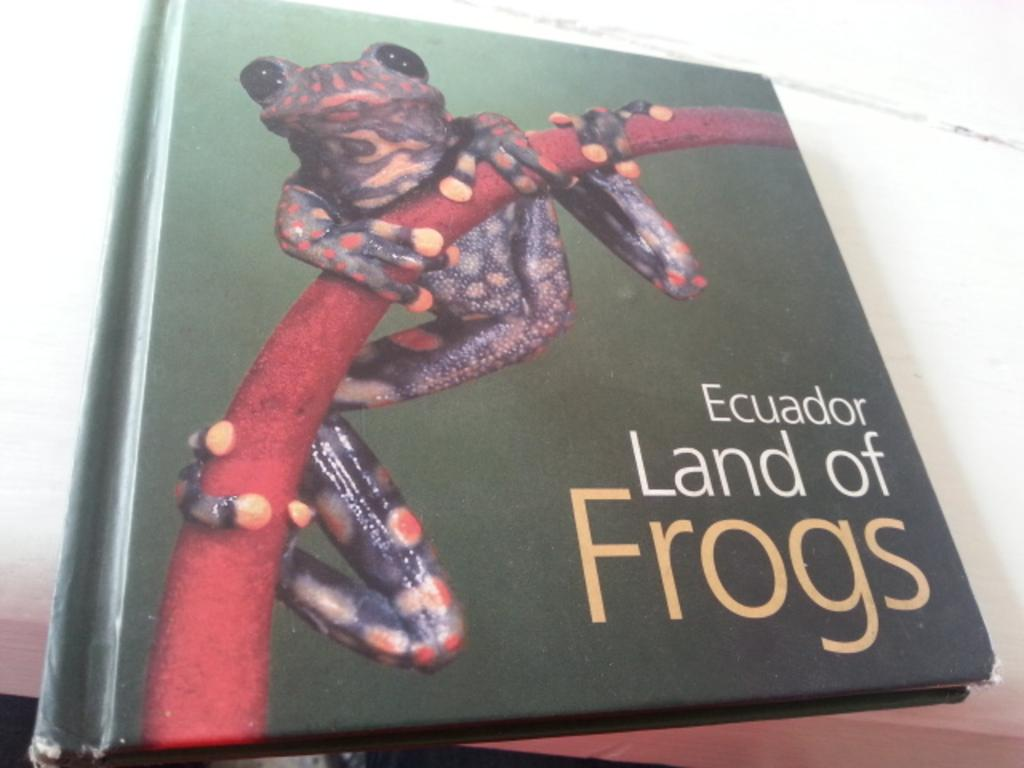<image>
Share a concise interpretation of the image provided. A book with a frog on it titled Ecuador Land of Frogs 